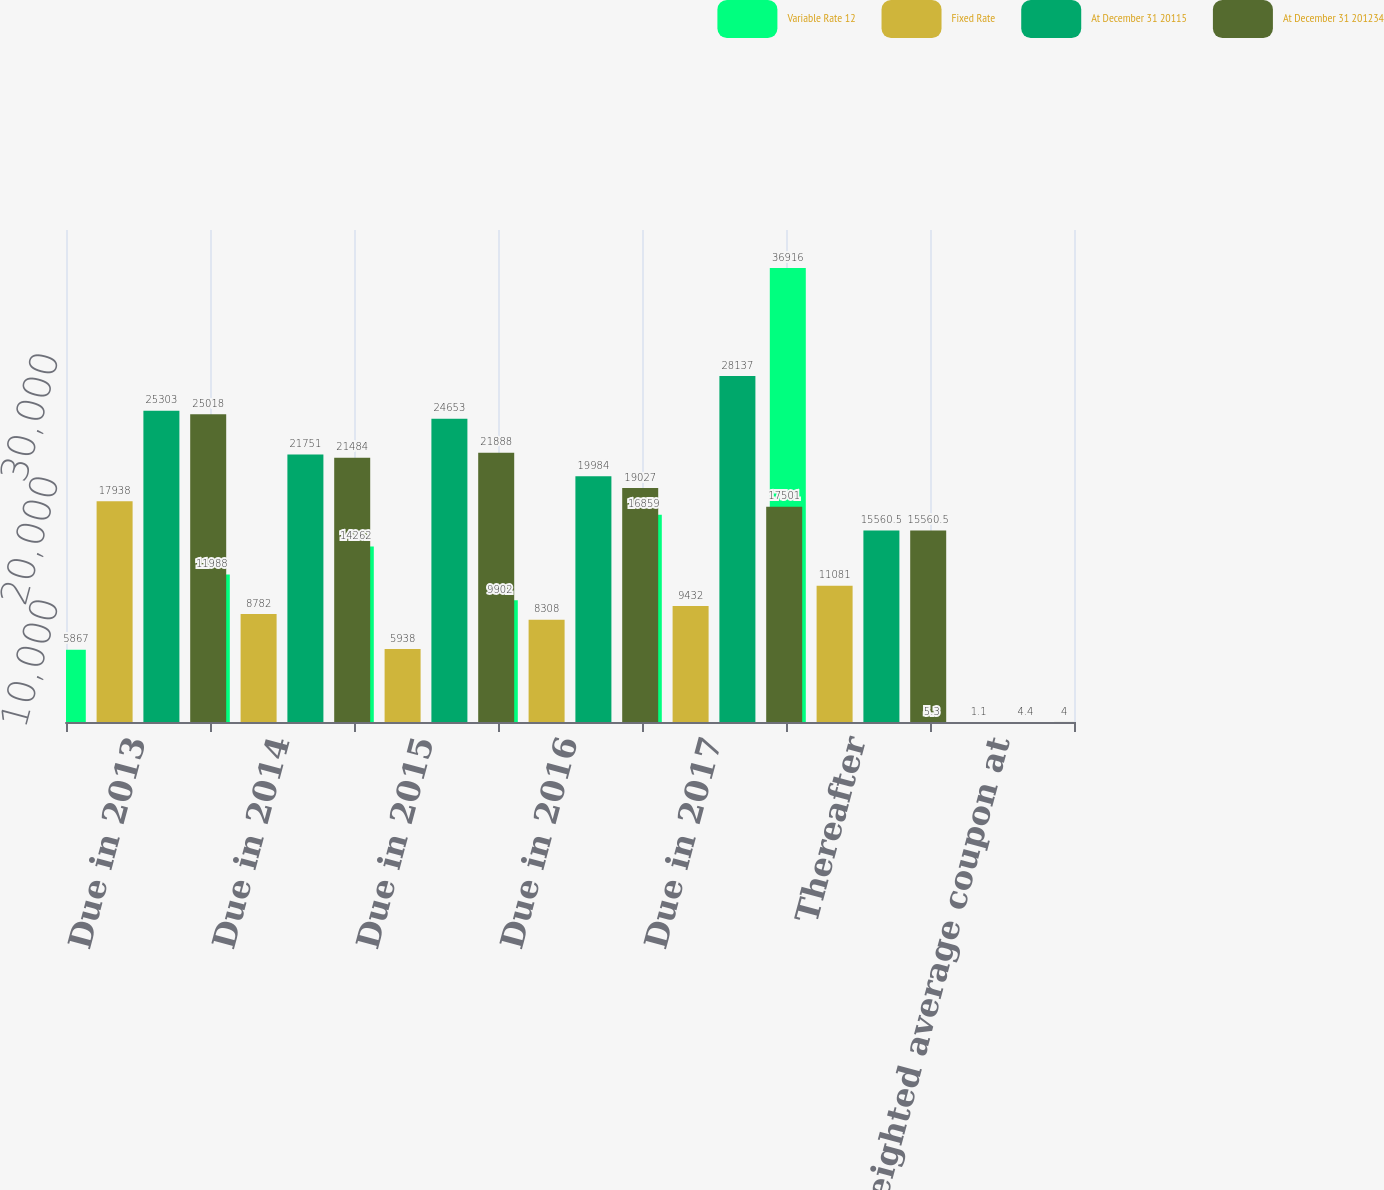<chart> <loc_0><loc_0><loc_500><loc_500><stacked_bar_chart><ecel><fcel>Due in 2013<fcel>Due in 2014<fcel>Due in 2015<fcel>Due in 2016<fcel>Due in 2017<fcel>Thereafter<fcel>Weighted average coupon at<nl><fcel>Variable Rate 12<fcel>5867<fcel>11988<fcel>14262<fcel>9902<fcel>16859<fcel>36916<fcel>5.3<nl><fcel>Fixed Rate<fcel>17938<fcel>8782<fcel>5938<fcel>8308<fcel>9432<fcel>11081<fcel>1.1<nl><fcel>At December 31 20115<fcel>25303<fcel>21751<fcel>24653<fcel>19984<fcel>28137<fcel>15560.5<fcel>4.4<nl><fcel>At December 31 201234<fcel>25018<fcel>21484<fcel>21888<fcel>19027<fcel>17501<fcel>15560.5<fcel>4<nl></chart> 